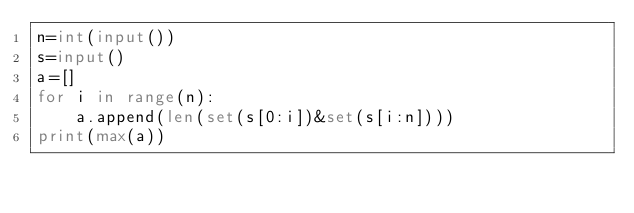<code> <loc_0><loc_0><loc_500><loc_500><_Python_>n=int(input())
s=input()
a=[]
for i in range(n):
    a.append(len(set(s[0:i])&set(s[i:n])))
print(max(a))</code> 